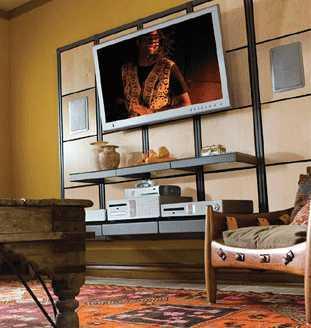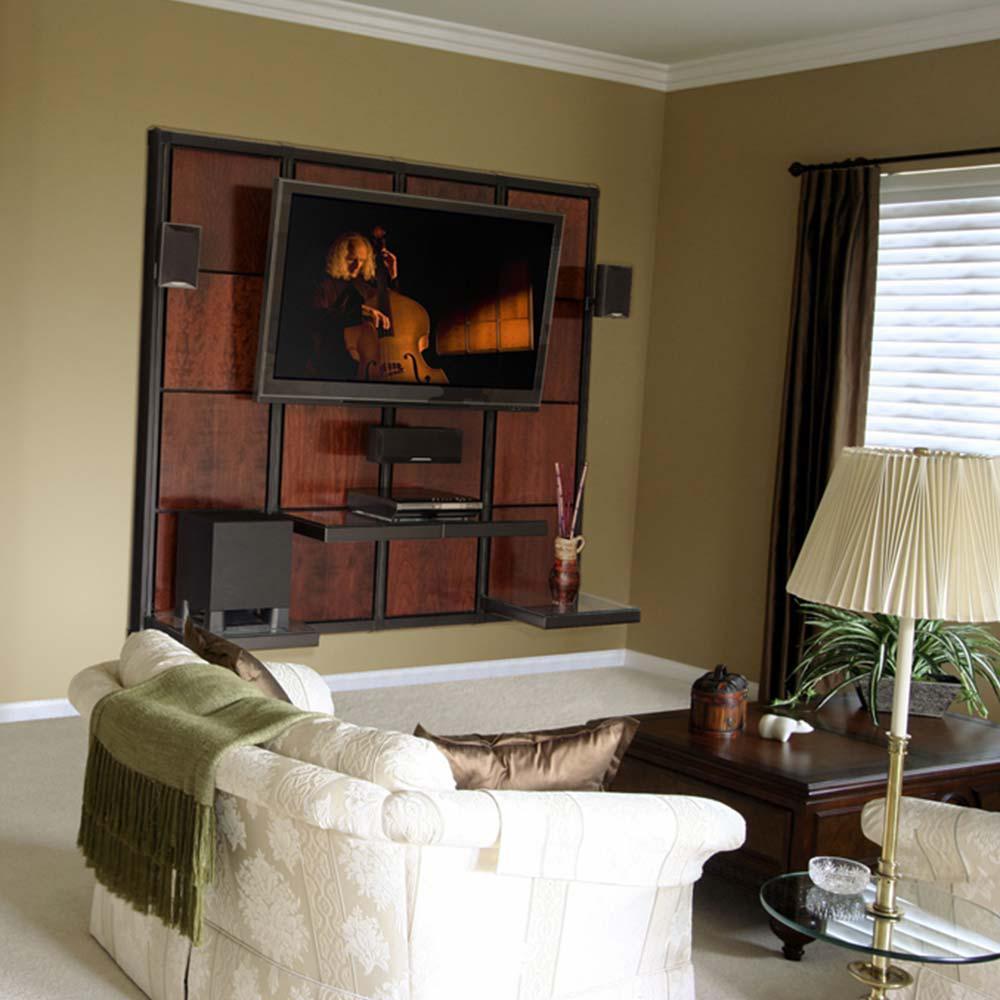The first image is the image on the left, the second image is the image on the right. Examine the images to the left and right. Is the description "At least one image has plants." accurate? Answer yes or no. Yes. The first image is the image on the left, the second image is the image on the right. Examine the images to the left and right. Is the description "Atleast one picture contains a white sofa" accurate? Answer yes or no. Yes. 